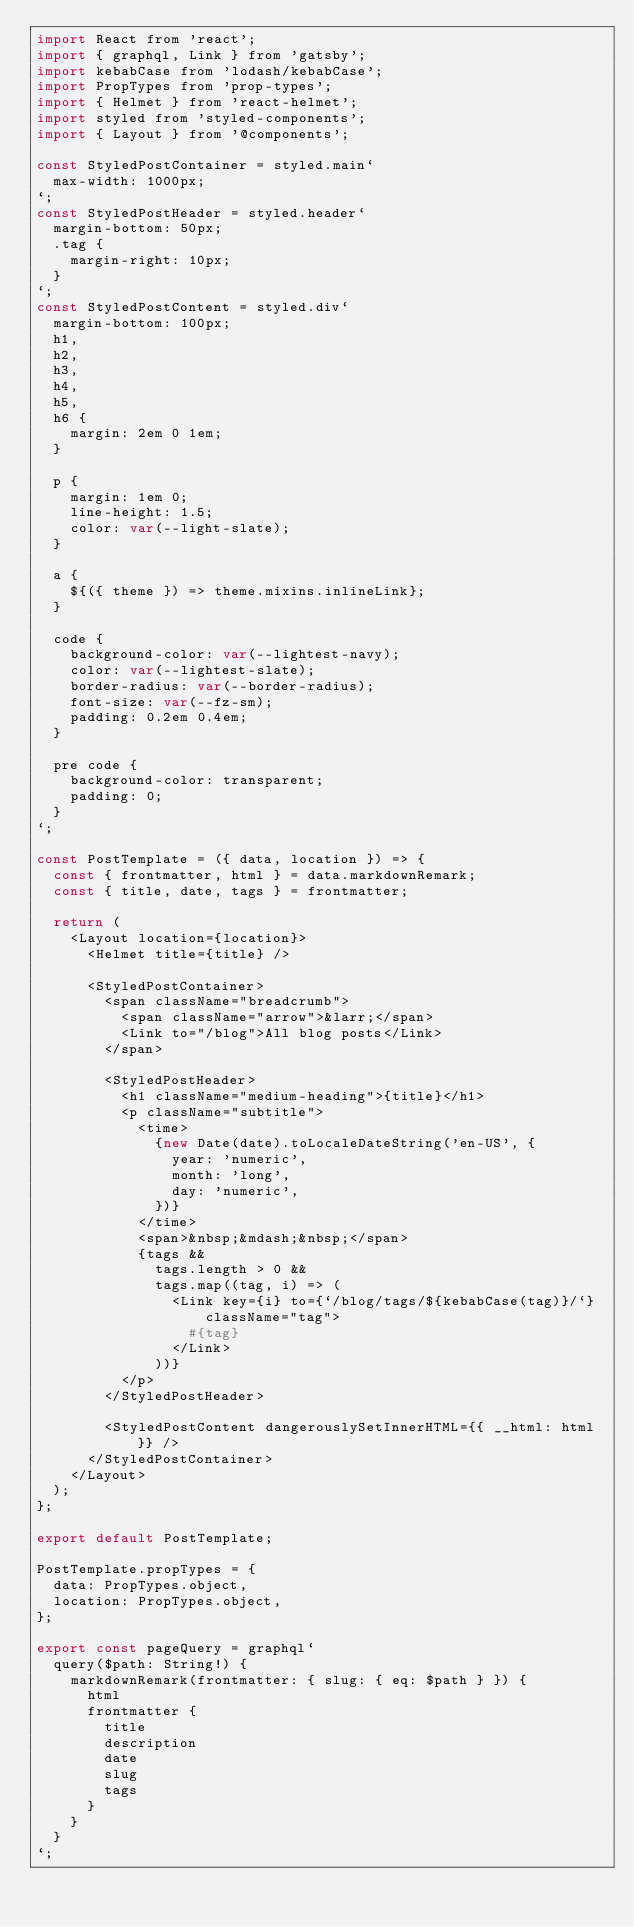<code> <loc_0><loc_0><loc_500><loc_500><_JavaScript_>import React from 'react';
import { graphql, Link } from 'gatsby';
import kebabCase from 'lodash/kebabCase';
import PropTypes from 'prop-types';
import { Helmet } from 'react-helmet';
import styled from 'styled-components';
import { Layout } from '@components';

const StyledPostContainer = styled.main`
  max-width: 1000px;
`;
const StyledPostHeader = styled.header`
  margin-bottom: 50px;
  .tag {
    margin-right: 10px;
  }
`;
const StyledPostContent = styled.div`
  margin-bottom: 100px;
  h1,
  h2,
  h3,
  h4,
  h5,
  h6 {
    margin: 2em 0 1em;
  }

  p {
    margin: 1em 0;
    line-height: 1.5;
    color: var(--light-slate);
  }

  a {
    ${({ theme }) => theme.mixins.inlineLink};
  }

  code {
    background-color: var(--lightest-navy);
    color: var(--lightest-slate);
    border-radius: var(--border-radius);
    font-size: var(--fz-sm);
    padding: 0.2em 0.4em;
  }

  pre code {
    background-color: transparent;
    padding: 0;
  }
`;

const PostTemplate = ({ data, location }) => {
  const { frontmatter, html } = data.markdownRemark;
  const { title, date, tags } = frontmatter;

  return (
    <Layout location={location}>
      <Helmet title={title} />

      <StyledPostContainer>
        <span className="breadcrumb">
          <span className="arrow">&larr;</span>
          <Link to="/blog">All blog posts</Link>
        </span>

        <StyledPostHeader>
          <h1 className="medium-heading">{title}</h1>
          <p className="subtitle">
            <time>
              {new Date(date).toLocaleDateString('en-US', {
                year: 'numeric',
                month: 'long',
                day: 'numeric',
              })}
            </time>
            <span>&nbsp;&mdash;&nbsp;</span>
            {tags &&
              tags.length > 0 &&
              tags.map((tag, i) => (
                <Link key={i} to={`/blog/tags/${kebabCase(tag)}/`} className="tag">
                  #{tag}
                </Link>
              ))}
          </p>
        </StyledPostHeader>

        <StyledPostContent dangerouslySetInnerHTML={{ __html: html }} />
      </StyledPostContainer>
    </Layout>
  );
};

export default PostTemplate;

PostTemplate.propTypes = {
  data: PropTypes.object,
  location: PropTypes.object,
};

export const pageQuery = graphql`
  query($path: String!) {
    markdownRemark(frontmatter: { slug: { eq: $path } }) {
      html
      frontmatter {
        title
        description
        date
        slug
        tags
      }
    }
  }
`;
</code> 